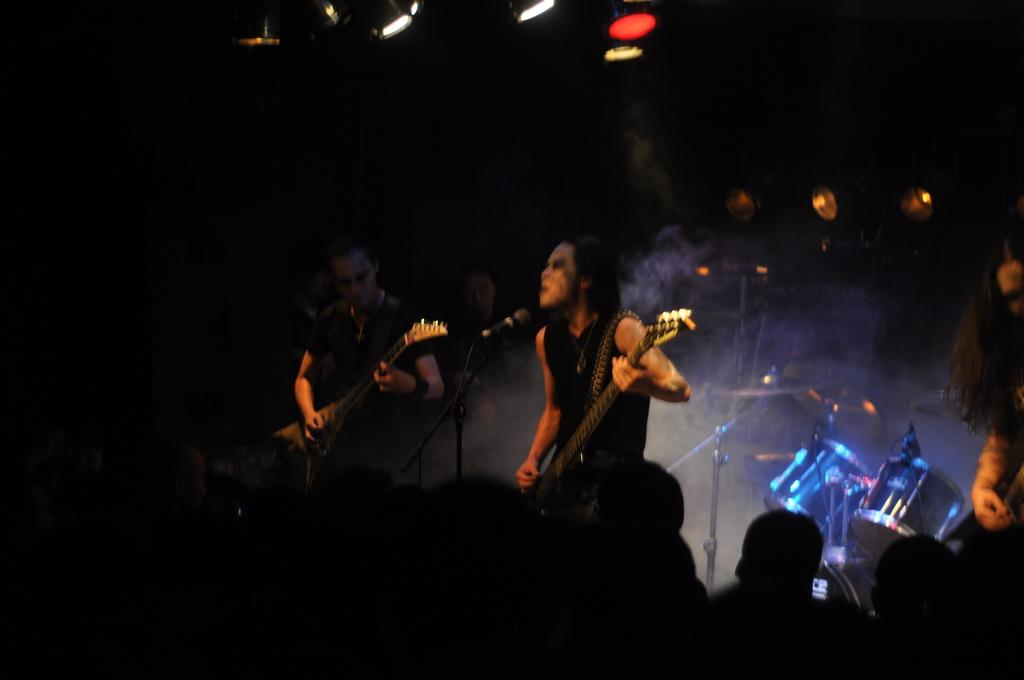How many people are in the image? There are two men in the image. What are the men holding in the image? The men are holding guitars. What are the men doing with the guitars? The men are playing the guitars. What is in front of the men? There is a microphone in front of the men. Who is watching the men play the guitars? There is an audience watching the men. What type of plantation can be seen in the background of the image? There is no plantation visible in the image; it features two men playing guitars with a microphone and an audience. 